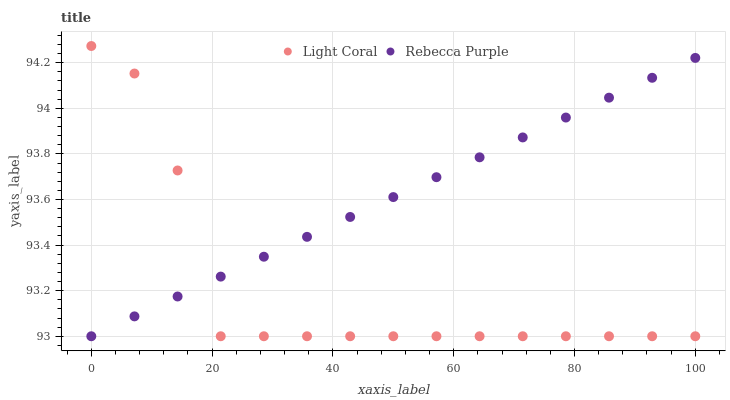Does Light Coral have the minimum area under the curve?
Answer yes or no. Yes. Does Rebecca Purple have the maximum area under the curve?
Answer yes or no. Yes. Does Rebecca Purple have the minimum area under the curve?
Answer yes or no. No. Is Rebecca Purple the smoothest?
Answer yes or no. Yes. Is Light Coral the roughest?
Answer yes or no. Yes. Is Rebecca Purple the roughest?
Answer yes or no. No. Does Light Coral have the lowest value?
Answer yes or no. Yes. Does Light Coral have the highest value?
Answer yes or no. Yes. Does Rebecca Purple have the highest value?
Answer yes or no. No. Does Light Coral intersect Rebecca Purple?
Answer yes or no. Yes. Is Light Coral less than Rebecca Purple?
Answer yes or no. No. Is Light Coral greater than Rebecca Purple?
Answer yes or no. No. 